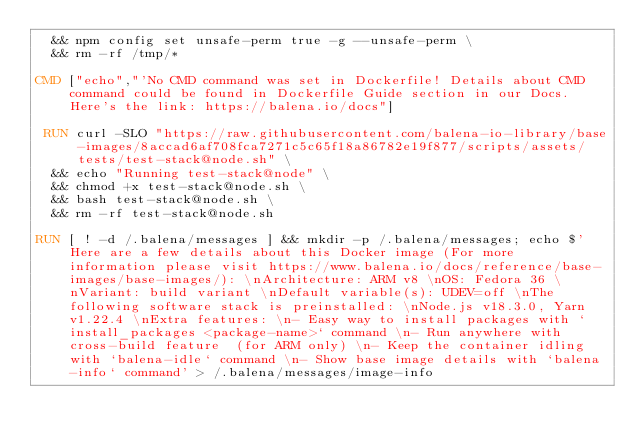<code> <loc_0><loc_0><loc_500><loc_500><_Dockerfile_>	&& npm config set unsafe-perm true -g --unsafe-perm \
	&& rm -rf /tmp/*

CMD ["echo","'No CMD command was set in Dockerfile! Details about CMD command could be found in Dockerfile Guide section in our Docs. Here's the link: https://balena.io/docs"]

 RUN curl -SLO "https://raw.githubusercontent.com/balena-io-library/base-images/8accad6af708fca7271c5c65f18a86782e19f877/scripts/assets/tests/test-stack@node.sh" \
  && echo "Running test-stack@node" \
  && chmod +x test-stack@node.sh \
  && bash test-stack@node.sh \
  && rm -rf test-stack@node.sh 

RUN [ ! -d /.balena/messages ] && mkdir -p /.balena/messages; echo $'Here are a few details about this Docker image (For more information please visit https://www.balena.io/docs/reference/base-images/base-images/): \nArchitecture: ARM v8 \nOS: Fedora 36 \nVariant: build variant \nDefault variable(s): UDEV=off \nThe following software stack is preinstalled: \nNode.js v18.3.0, Yarn v1.22.4 \nExtra features: \n- Easy way to install packages with `install_packages <package-name>` command \n- Run anywhere with cross-build feature  (for ARM only) \n- Keep the container idling with `balena-idle` command \n- Show base image details with `balena-info` command' > /.balena/messages/image-info</code> 